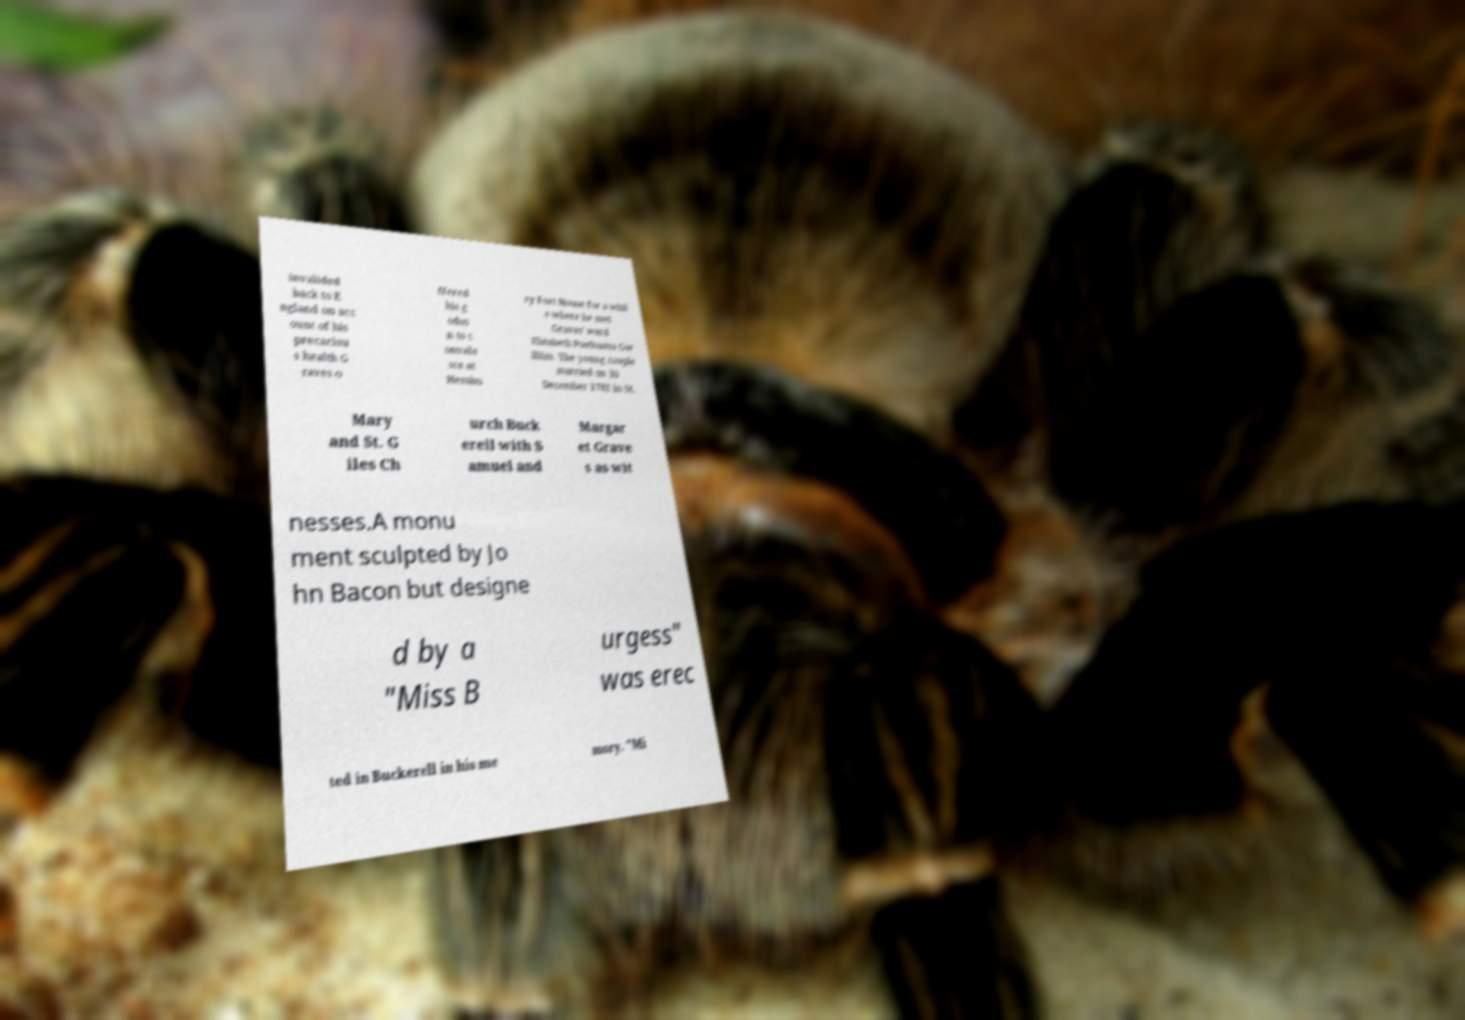Please read and relay the text visible in this image. What does it say? invalided back to E ngland on acc ount of his precariou s health G raves o ffered his g odso n to c onvale sce at Hembu ry Fort House for a whil e where he met Graves' ward Elizabeth Posthuma Gw illim. The young couple married on 30 December 1782 in St. Mary and St. G iles Ch urch Buck erell with S amuel and Margar et Grave s as wit nesses.A monu ment sculpted by Jo hn Bacon but designe d by a "Miss B urgess" was erec ted in Buckerell in his me mory. "Mi 